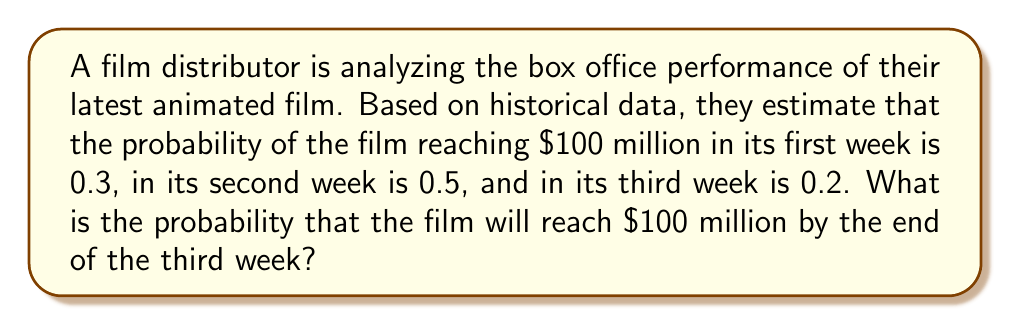Provide a solution to this math problem. Let's approach this step-by-step:

1) First, we need to recognize that this is a problem of cumulative probability. We're looking for the probability of the event occurring in the first week OR the second week OR the third week.

2) Let's define our events:
   A: The film reaches $100 million in the first week
   B: The film reaches $100 million in the second week
   C: The film reaches $100 million in the third week

3) We're given the following probabilities:
   $P(A) = 0.3$
   $P(B) = 0.5$
   $P(C) = 0.2$

4) To find the probability of the film reaching $100 million by the end of the third week, we need to calculate $P(A \cup B \cup C)$

5) Using the addition rule of probability:

   $P(A \cup B \cup C) = P(A) + P(B) + P(C) - P(A \cap B) - P(A \cap C) - P(B \cap C) + P(A \cap B \cap C)$

6) However, these events are mutually exclusive. If the film reaches $100 million in the first week, it can't reach it again in the second or third week. This means all the intersection terms are zero.

7) Therefore, our equation simplifies to:

   $P(A \cup B \cup C) = P(A) + P(B) + P(C)$

8) Substituting the given probabilities:

   $P(A \cup B \cup C) = 0.3 + 0.5 + 0.2 = 1$

9) This makes sense intuitively as well. The probabilities sum to 1, meaning the film is certain to reach $100 million by the end of the third week.
Answer: 1 